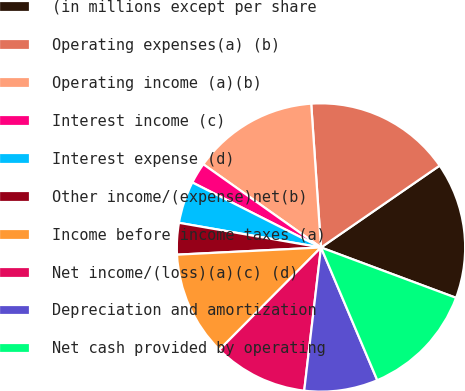Convert chart to OTSL. <chart><loc_0><loc_0><loc_500><loc_500><pie_chart><fcel>(in millions except per share<fcel>Operating expenses(a) (b)<fcel>Operating income (a)(b)<fcel>Interest income (c)<fcel>Interest expense (d)<fcel>Other income/(expense)net(b)<fcel>Income before income taxes (a)<fcel>Net income/(loss)(a)(c) (d)<fcel>Depreciation and amortization<fcel>Net cash provided by operating<nl><fcel>15.29%<fcel>16.47%<fcel>14.12%<fcel>2.35%<fcel>4.71%<fcel>3.53%<fcel>11.76%<fcel>10.59%<fcel>8.24%<fcel>12.94%<nl></chart> 